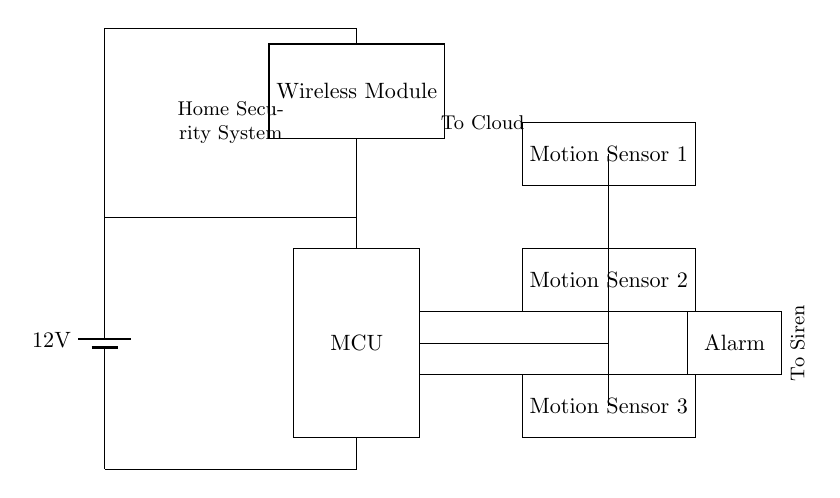What is the voltage of the power supply? The circuit diagram shows a battery symbol labeled with 12V, indicating the power supply voltage.
Answer: 12V What components are connected to the microcontroller? The components connected to the microcontroller include the wireless module and three motion sensors, as depicted by the lines showing connections in the diagram.
Answer: Wireless module and motion sensors How many motion sensors are present in this circuit? The diagram clearly shows three distinct motion sensor blocks labeled as Motion Sensor 1, Motion Sensor 2, and Motion Sensor 3.
Answer: Three What is the function of the wireless module? The wireless module sends and receives signals to and from the cloud, which is indicated by a label in the diagram showing "To Cloud".
Answer: Wireless communication Where does the alarm connect in the circuit? The alarm is directly connected to the microcontroller via a line showing the connection, and it is indicated with an arrow pointing toward the alarm labeled "To Siren".
Answer: To the microcontroller What is the output voltage of this security system? The components in the diagram do not give an explicit output voltage, but since they all connect to the 12V power supply, we can infer that the operating voltage is the same as the power supply.
Answer: 12V What is the role of the motion sensors in this circuit? The motion sensors detect motion within their range; when motion is detected, they send a signal to the microcontroller, which can then trigger the alarm or other actions. This function is understood by the placement and connections in the diagram.
Answer: Motion detection 